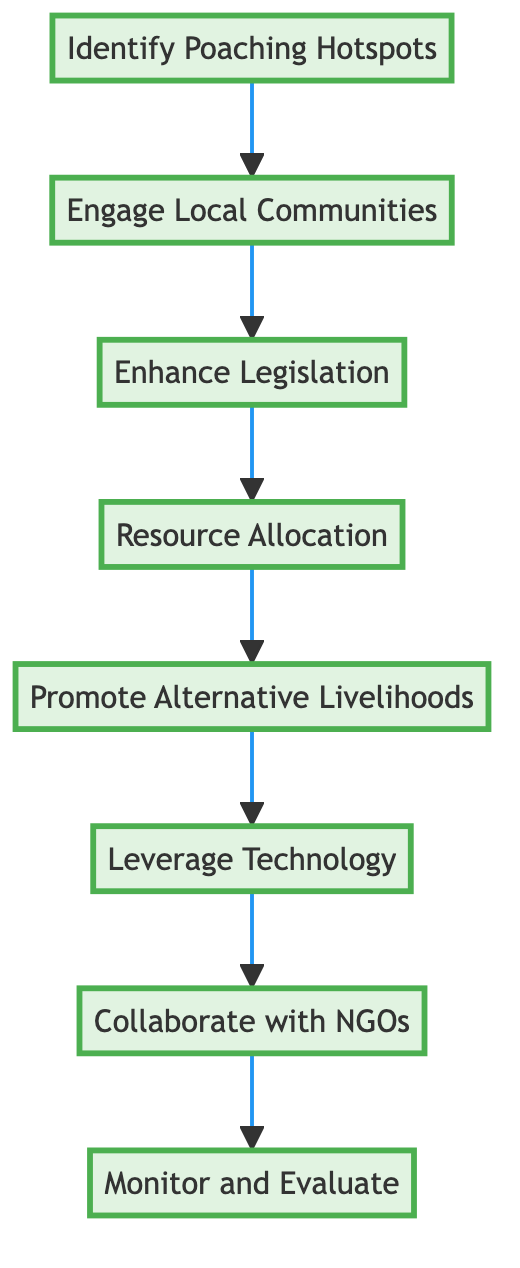What is the first step in the anti-poaching policy? The first step in the diagram is "Identify Poaching Hotspots," which is explicitly indicated as the starting node.
Answer: Identify Poaching Hotspots How many steps are there in the flow chart? The diagram contains a total of eight steps, which are all visually represented in sequential order from the start to the end.
Answer: Eight What is the last step in the process? The last step at the end of the flow chart is "Monitor and Evaluate," which signifies the conclusion of the anti-poaching policy steps.
Answer: Monitor and Evaluate Which step directly follows "Enhance Legislation"? The step that directly follows "Enhance Legislation" in the sequence is "Resource Allocation," as observed in the flow from one node to the next.
Answer: Resource Allocation What action is suggested before promoting alternative livelihoods? Before promoting alternative livelihoods, the flow chart suggests "Resource Allocation," indicating that resources should be allocated effectively first.
Answer: Resource Allocation Which two steps are connected by an arrow before the last step? The two steps connected just before the last step are "Collaborate with NGOs" and "Monitor and Evaluate," reflecting the progression towards final evaluation.
Answer: Collaborate with NGOs and Monitor and Evaluate Which step involves integrating advanced technologies? The step that involves integrating advanced technologies is "Leverage Technology," which is specifically highlighted in the flow chart as a crucial part of the process.
Answer: Leverage Technology What step emphasizes working with local communities? The step that emphasizes working with local communities is "Engage Local Communities," which follows naturally after identifying hotspots to involve community perspectives.
Answer: Engage Local Communities 